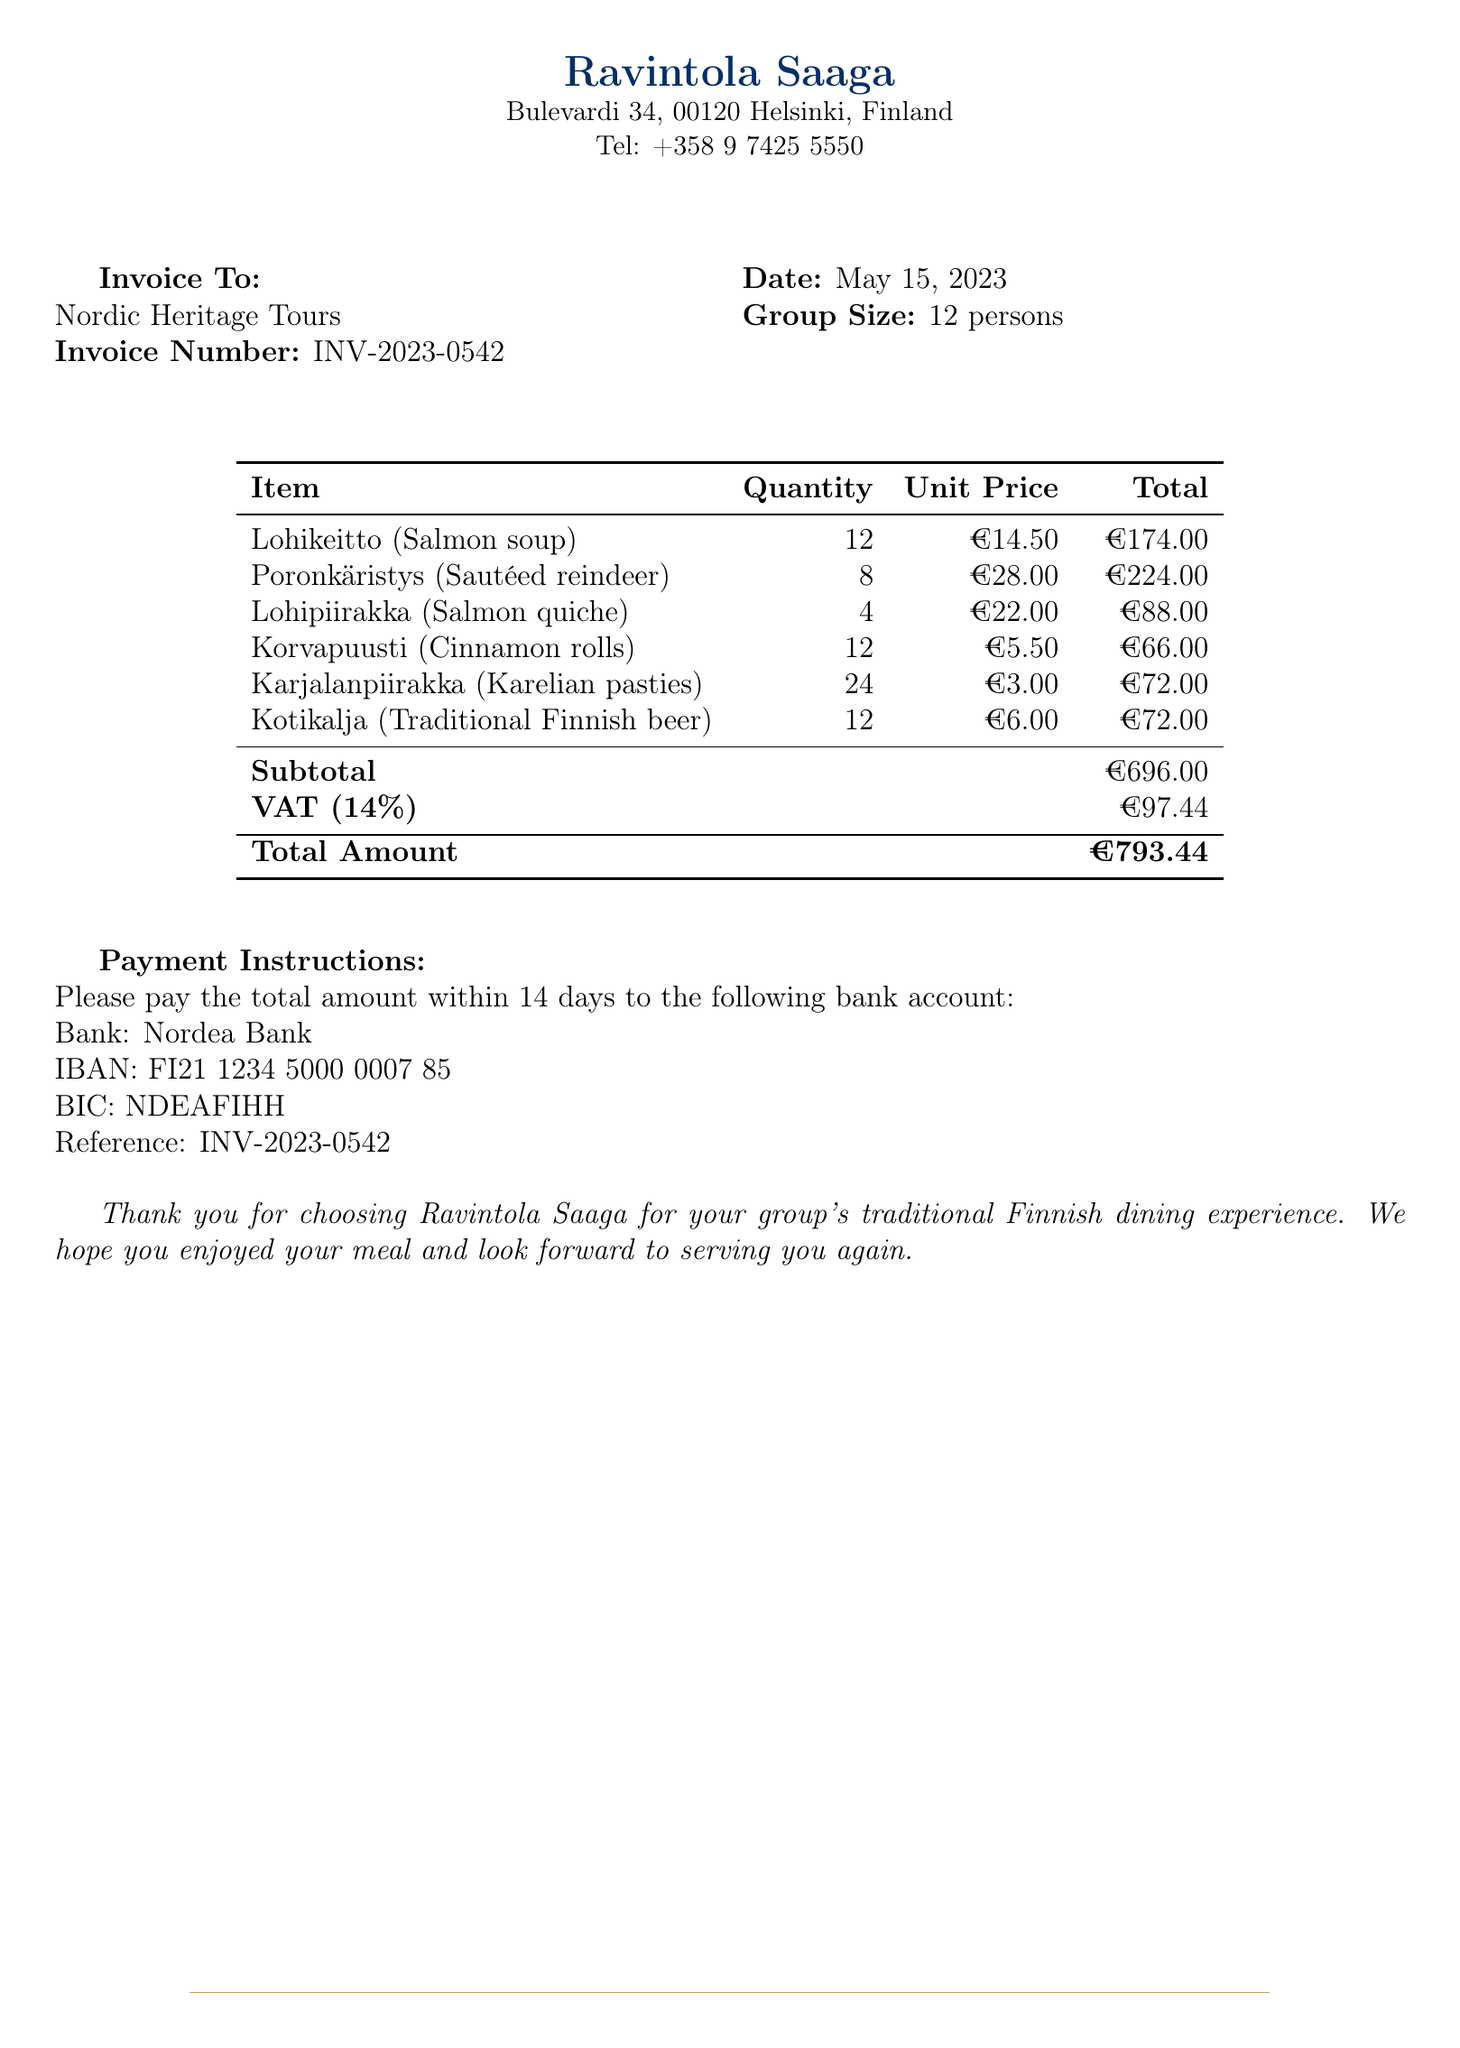What is the invoice number? The invoice number is a unique identifier for this transaction mentioned in the document.
Answer: INV-2023-0542 What is the date of the invoice? The date of the invoice is indicated near the invoice number and represents when the invoice was issued.
Answer: May 15, 2023 How many persons are in the group? The document specifies the group size which is essential for understanding the scale of the meal requested.
Answer: 12 persons What is the total amount due? The total amount is the final sum that needs to be paid, as stated at the bottom of the invoice.
Answer: €793.44 How much is the VAT applied? The document states the VAT amount, which is a tax included in the total costs of the meal.
Answer: €97.44 What traditional dish has the highest cost per unit? The item with the highest unit price indicates the most expensive dish ordered from the menu.
Answer: Poronkäristys (Sautéed reindeer) What is the payment instruction? This refers to the section detailing how to make the payment for the invoice, crucial for processing the payment properly.
Answer: Please pay the total amount within 14 days to the following bank account How many Lohikeitto dishes were ordered? This counts the quantity of a specific dish as part of the meal selection, which is vital for understanding the group's preferences.
Answer: 12 What is the IBAN for payment? The IBAN is the specific bank account number required for the payment transaction, essential for its processing.
Answer: FI21 1234 5000 0007 85 